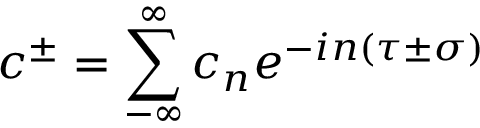<formula> <loc_0><loc_0><loc_500><loc_500>c ^ { \pm } = \sum _ { - \infty } ^ { \infty } c _ { n } e ^ { - i n \left ( \tau \pm \sigma \right ) }</formula> 